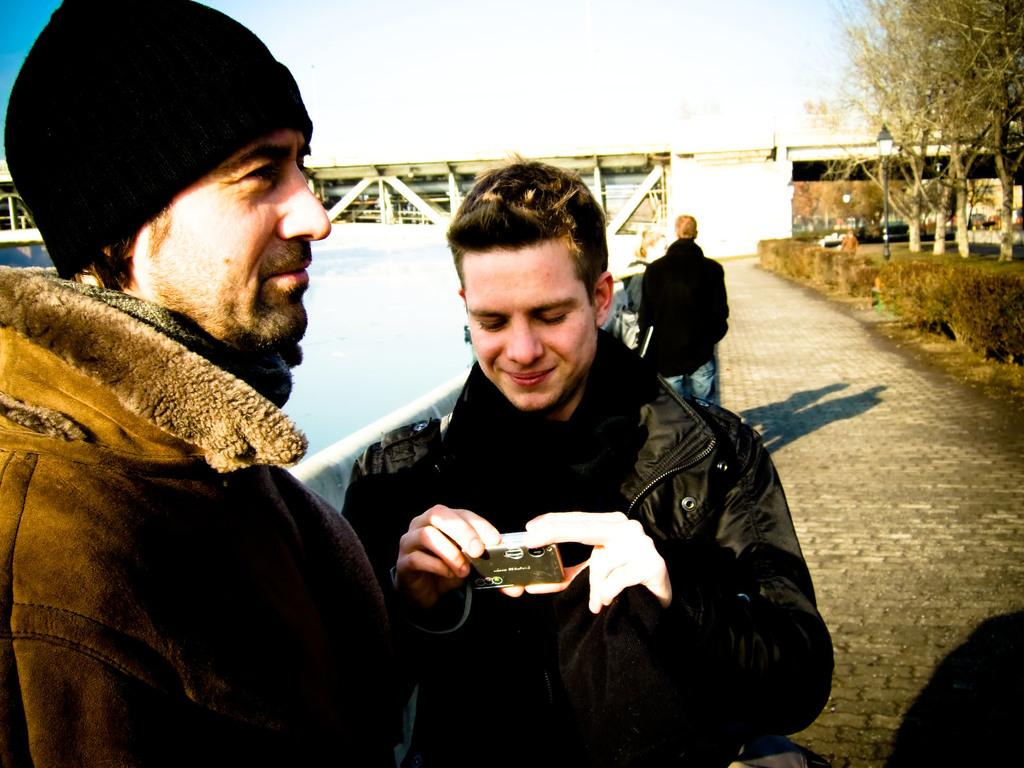How many people are in the image? There are two persons standing on the floor in the image. What are the persons holding in their hands? The persons are holding objects in their hands. What can be seen in the background of the image? There is water, trees, and the sky visible in the image. How many cats are playing with a pail in the image? There are no cats or pails present in the image. What type of waste can be seen in the image? There is no waste visible in the image. 